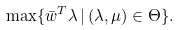Convert formula to latex. <formula><loc_0><loc_0><loc_500><loc_500>\max \{ \bar { w } ^ { T } \lambda \, | \, ( \lambda , \mu ) \in \Theta \} .</formula> 